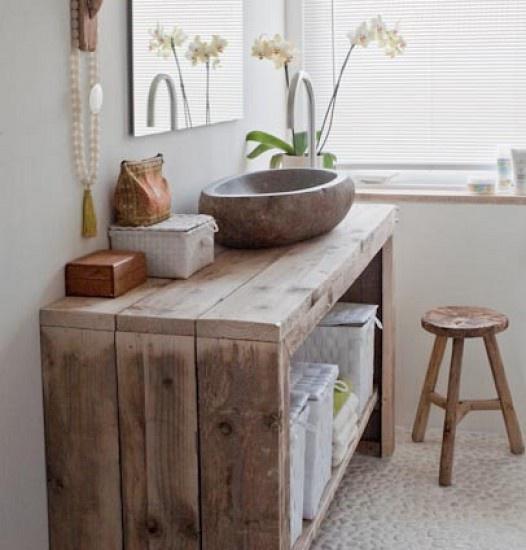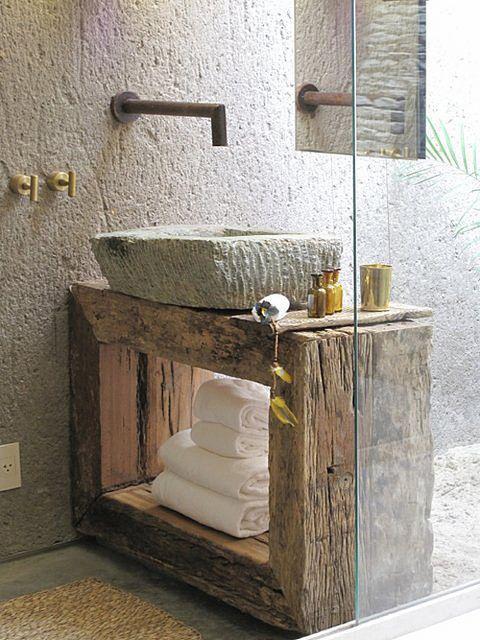The first image is the image on the left, the second image is the image on the right. Considering the images on both sides, is "All sinks shown sit on top of a vanity, at least some vanities have wood grain, and white towels are underneath at least one vanity." valid? Answer yes or no. Yes. The first image is the image on the left, the second image is the image on the right. Given the left and right images, does the statement "A mirror sits behind the sink in each of the images." hold true? Answer yes or no. No. 